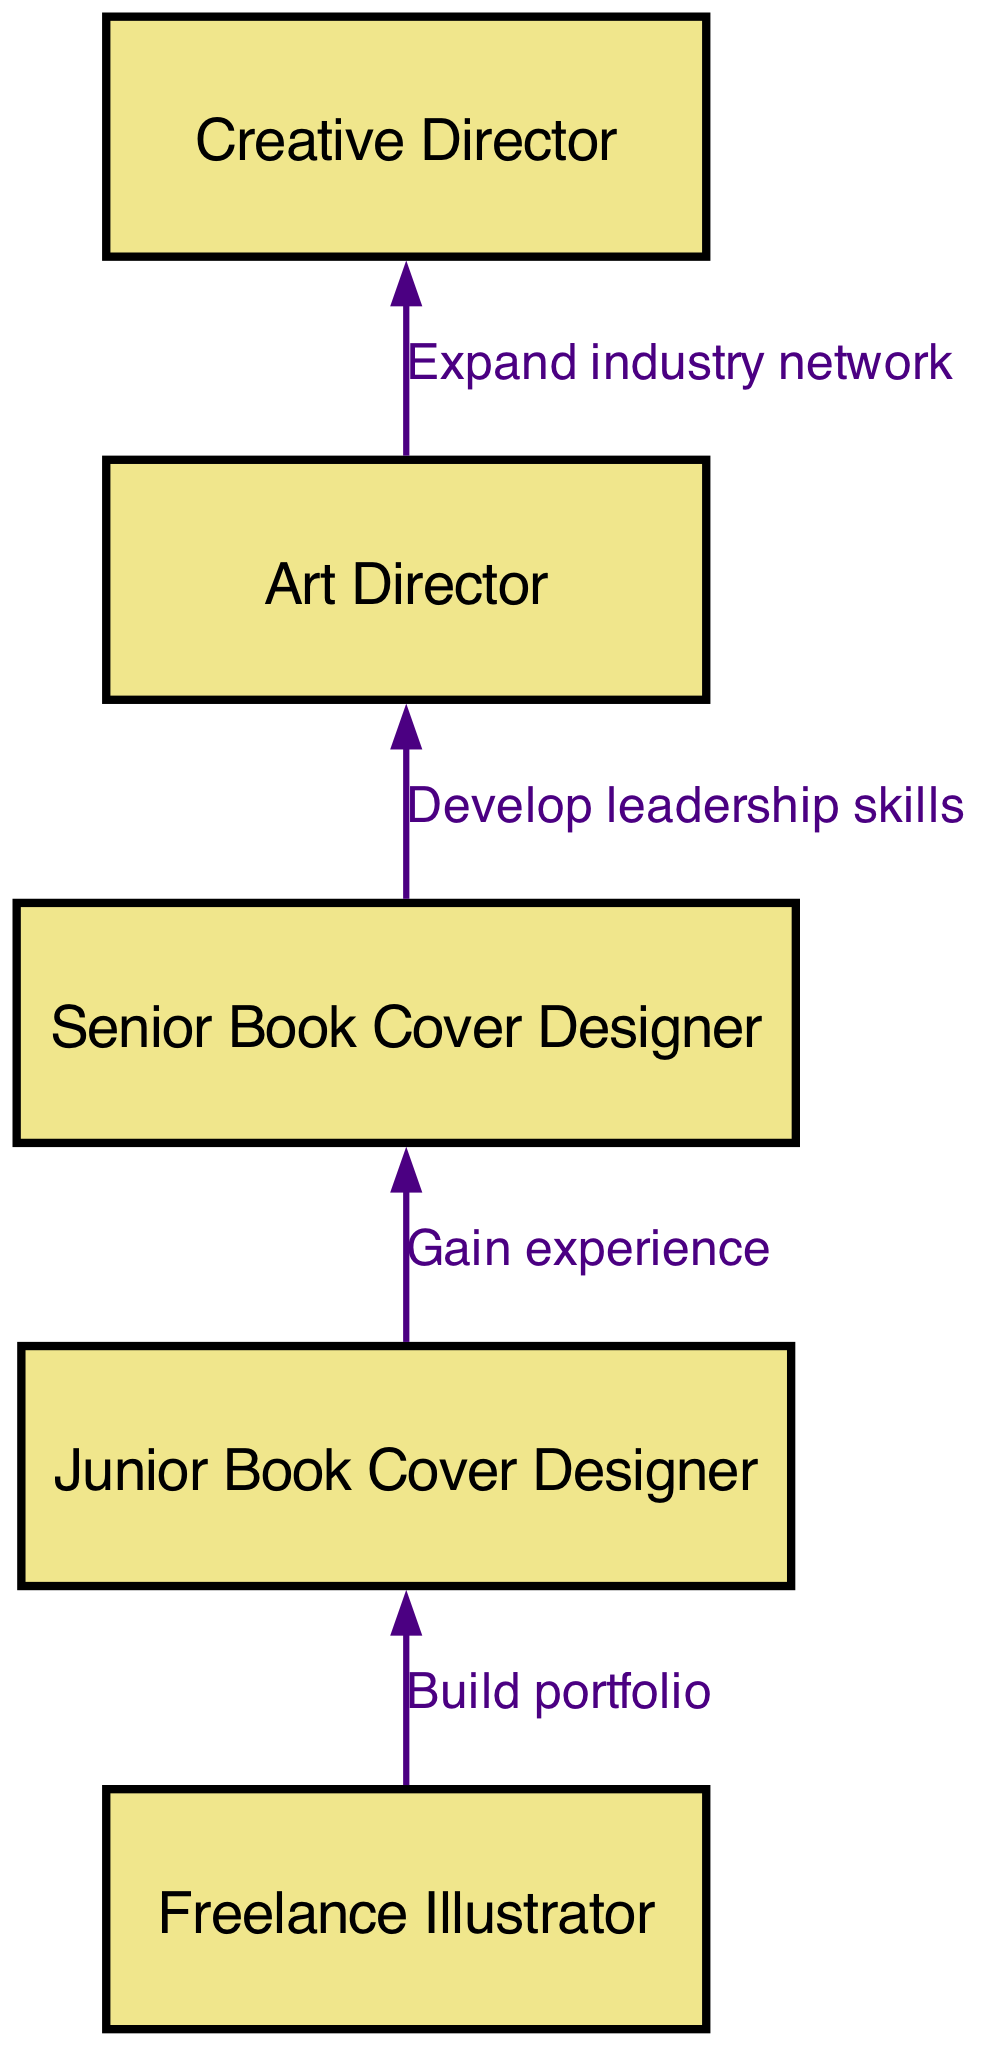What is the starting position for aspiring book cover illustrators? The diagram begins with the "Freelance Illustrator" node, which represents the starting point in the career progression path.
Answer: Freelance Illustrator How many nodes are in the diagram? The diagram contains a total of 5 nodes, which represent different positions in the career progression path.
Answer: 5 What is the relationship between "Junior Book Cover Designer" and "Senior Book Cover Designer"? The edge between these two nodes is labeled "Gain experience," indicating that gaining experience as a Junior Designer leads to the next step of becoming a Senior Designer.
Answer: Gain experience What is the final position in the career progression path? The final node in the progression is "Creative Director," which signifies the highest level in this career path.
Answer: Creative Director What skill is developed when moving from "Senior Book Cover Designer" to "Art Director"? The transition is related to "Develop leadership skills," indicating that at this stage, enhancing leadership capabilities is essential for advancement.
Answer: Develop leadership skills Which two positions are directly connected, indicating a progression in experience? The "Junior Book Cover Designer" and "Senior Book Cover Designer" nodes are directly connected, showing that one role builds on the experience of the prior role.
Answer: Junior Book Cover Designer, Senior Book Cover Designer What is the purpose of expanding an industry network in this career progression? This action is essential for advancing from "Art Director" to "Creative Director," as it emphasizes the importance of networking in higher-level roles.
Answer: Expand industry network What do all the arrows in the diagram represent? Each arrow indicates the progression from one role to the next, showing the steps required to advance in a book cover illustrator's career.
Answer: Progression steps 